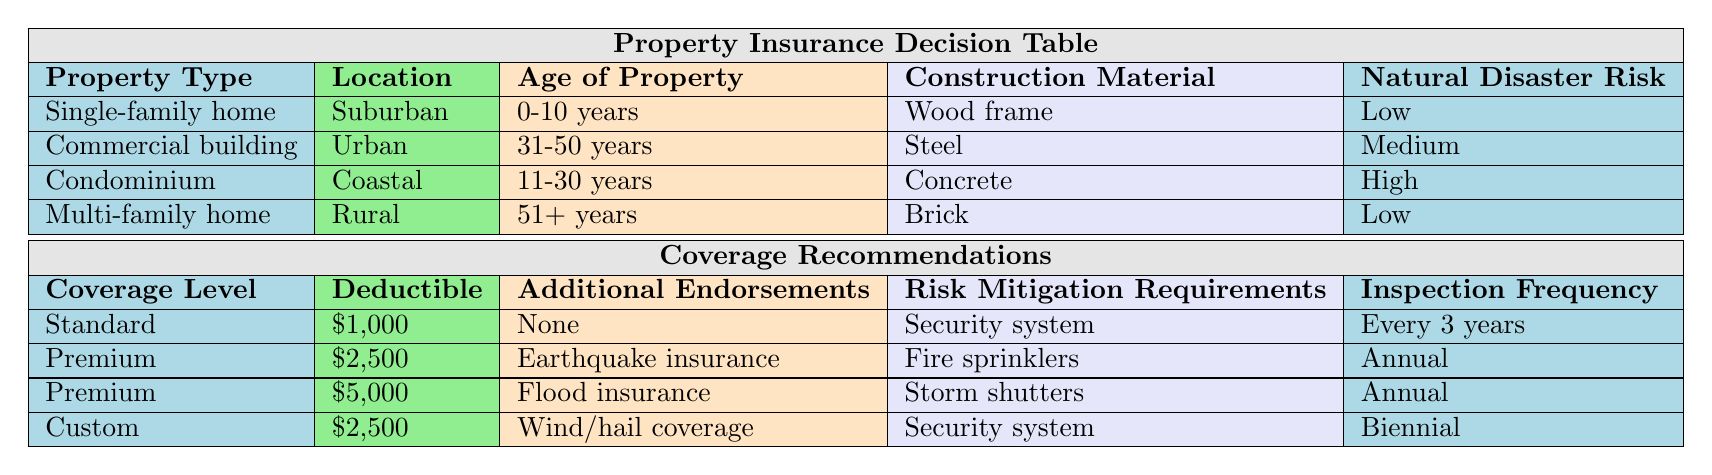What coverage level is recommended for a single-family home in a suburban area? The row corresponding to a single-family home located in a suburban area shows a coverage level of Standard.
Answer: Standard Is the deductible for a commercial building higher than that for a multi-family home? The deductible for a commercial building is $2,500, while the deductible for a multi-family home is $2,500 as well. Therefore, the deducible amounts are equal, not higher.
Answer: No What is the inspection frequency for properties that have a premium coverage level? Two properties, the commercial building and the condominium, have a premium coverage level. Both require an inspection frequency of Annual.
Answer: Annual Which construction material has the maximum deductible amount among the listed properties? By checking the deductibles across different construction materials, the highest deductible amount of $5,000 is associated with a condominium, made of concrete.
Answer: Concrete If a property is located in a coastal area, what type of natural disaster risk is it likely to face based on the table? The condominium situated in the coastal area categorizes the natural disaster risk as High, indicating that coastal properties are associated with this risk level.
Answer: High For properties with low natural disaster risk, what is the required risk mitigation requirement? There are two properties with low natural disaster risk - the single-family home and the multi-family home. Both require a security system for risk mitigation.
Answer: Security system What is the average deductible for the properties that have a standard coverage level? From the table, only the single-family home has a standard coverage level, which has a deductible of $1,000. Therefore, the average is simply $1,000.
Answer: $1,000 If a property is over 50 years old and multi-family, what coverage level is recommended? The multi-family home is 51+ years old and is associated with Custom coverage level as per the rules.
Answer: Custom Is it true that all properties with high natural disaster risk require annual inspections? In the table, the only property with high natural disaster risk is the condominium, which does require an annual inspection. Therefore, the statement is true for the information given.
Answer: Yes 